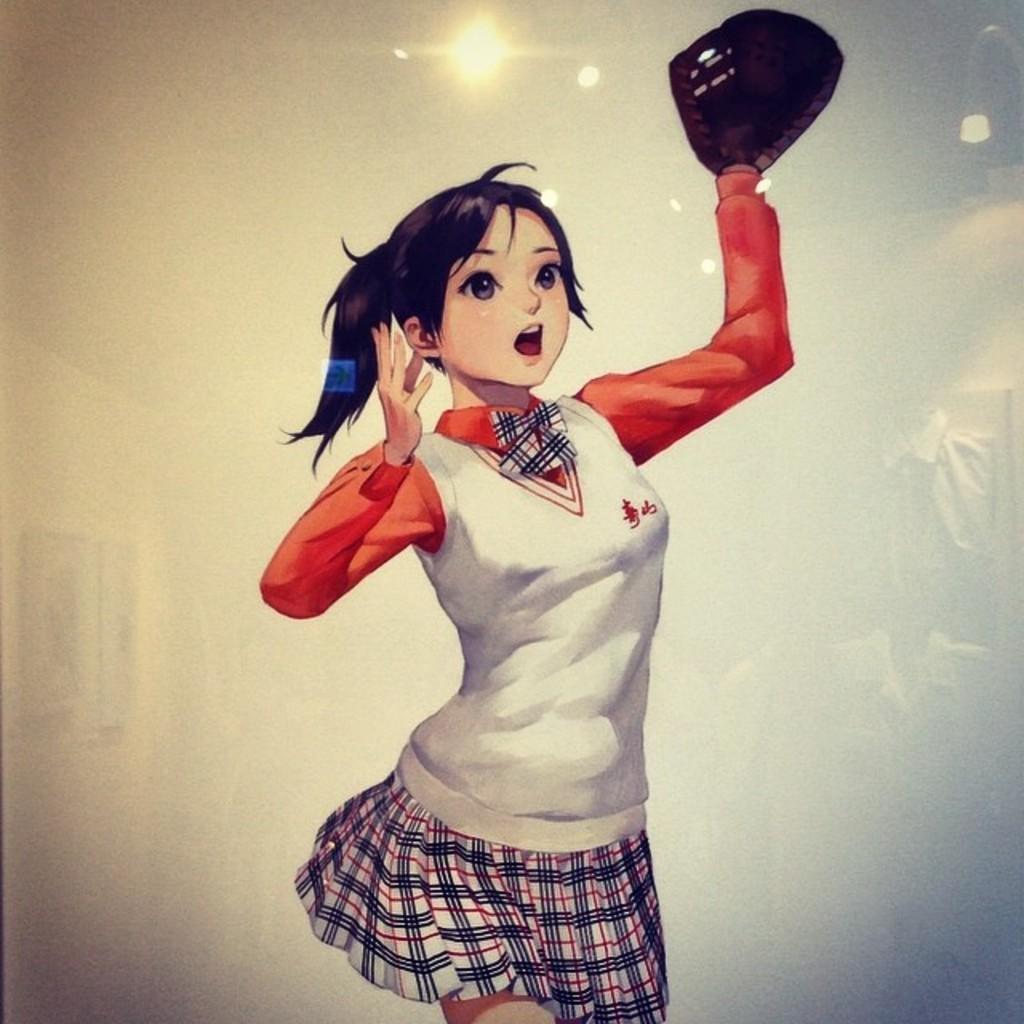Can you describe this image briefly? This image looks like a depiction in which I can see a woman is holding some object in hand, photo frames on a wall and lights. 